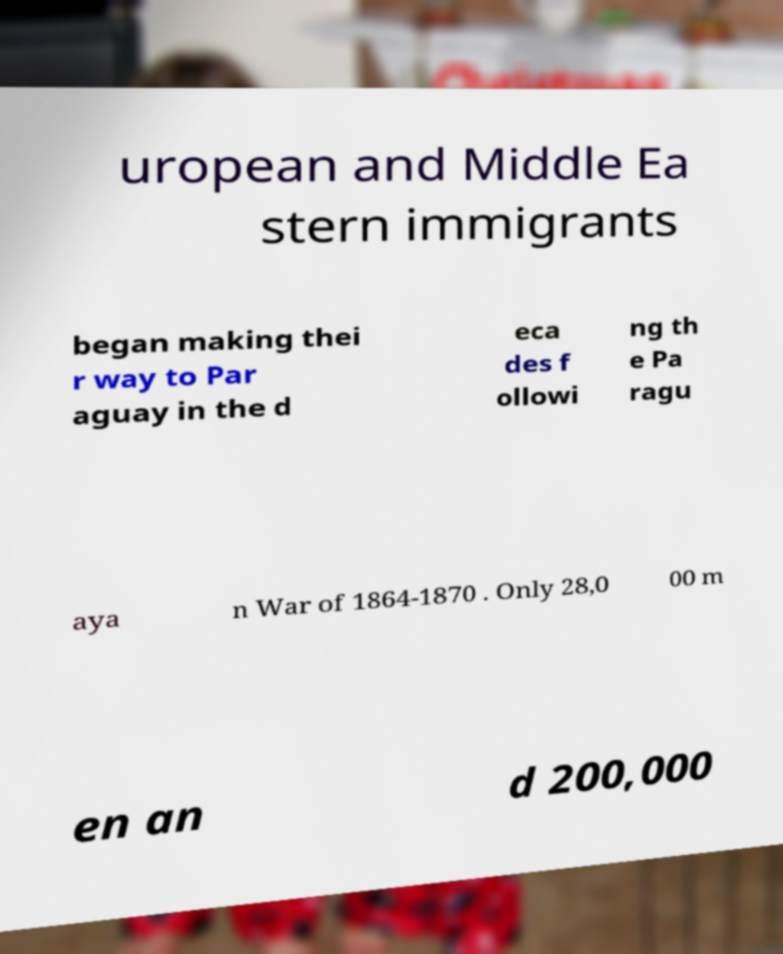For documentation purposes, I need the text within this image transcribed. Could you provide that? uropean and Middle Ea stern immigrants began making thei r way to Par aguay in the d eca des f ollowi ng th e Pa ragu aya n War of 1864-1870 . Only 28,0 00 m en an d 200,000 